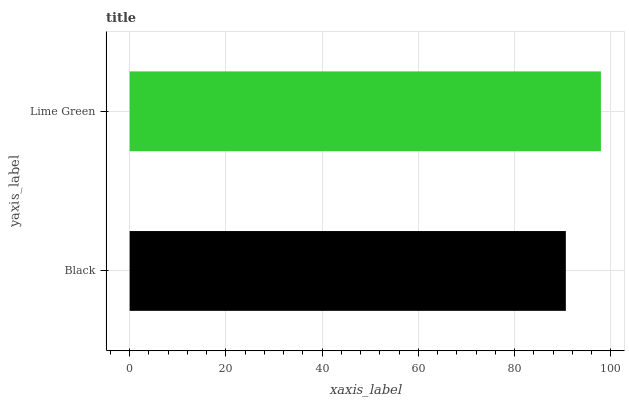Is Black the minimum?
Answer yes or no. Yes. Is Lime Green the maximum?
Answer yes or no. Yes. Is Lime Green the minimum?
Answer yes or no. No. Is Lime Green greater than Black?
Answer yes or no. Yes. Is Black less than Lime Green?
Answer yes or no. Yes. Is Black greater than Lime Green?
Answer yes or no. No. Is Lime Green less than Black?
Answer yes or no. No. Is Lime Green the high median?
Answer yes or no. Yes. Is Black the low median?
Answer yes or no. Yes. Is Black the high median?
Answer yes or no. No. Is Lime Green the low median?
Answer yes or no. No. 